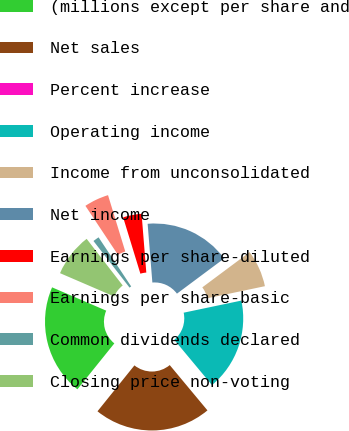Convert chart. <chart><loc_0><loc_0><loc_500><loc_500><pie_chart><fcel>(millions except per share and<fcel>Net sales<fcel>Percent increase<fcel>Operating income<fcel>Income from unconsolidated<fcel>Net income<fcel>Earnings per share-diluted<fcel>Earnings per share-basic<fcel>Common dividends declared<fcel>Closing price non-voting<nl><fcel>20.69%<fcel>21.84%<fcel>0.0%<fcel>17.24%<fcel>6.9%<fcel>16.09%<fcel>3.45%<fcel>4.6%<fcel>1.15%<fcel>8.05%<nl></chart> 